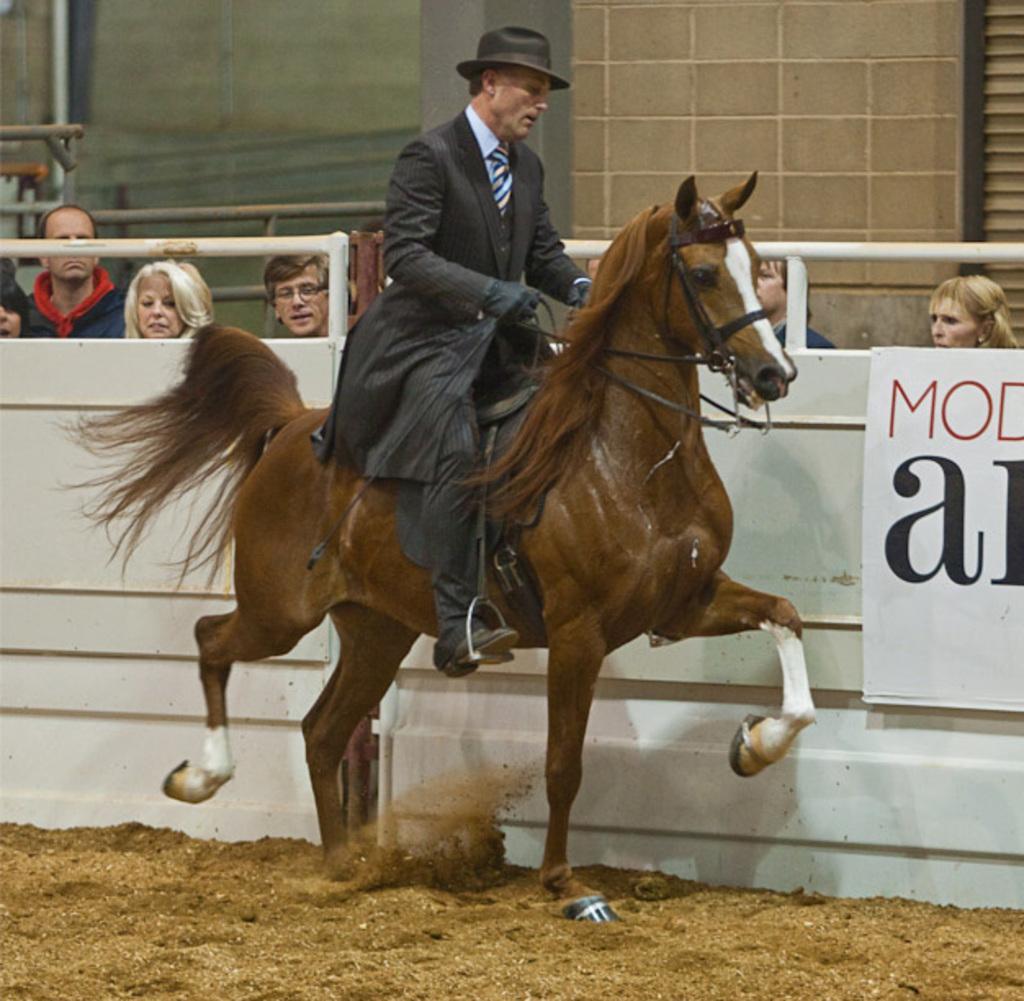In one or two sentences, can you explain what this image depicts? In the center of the picture there is a man riding a horse. In the foreground there is sand. In the center the picture there is railing and few people standing. In the background there is wall. 